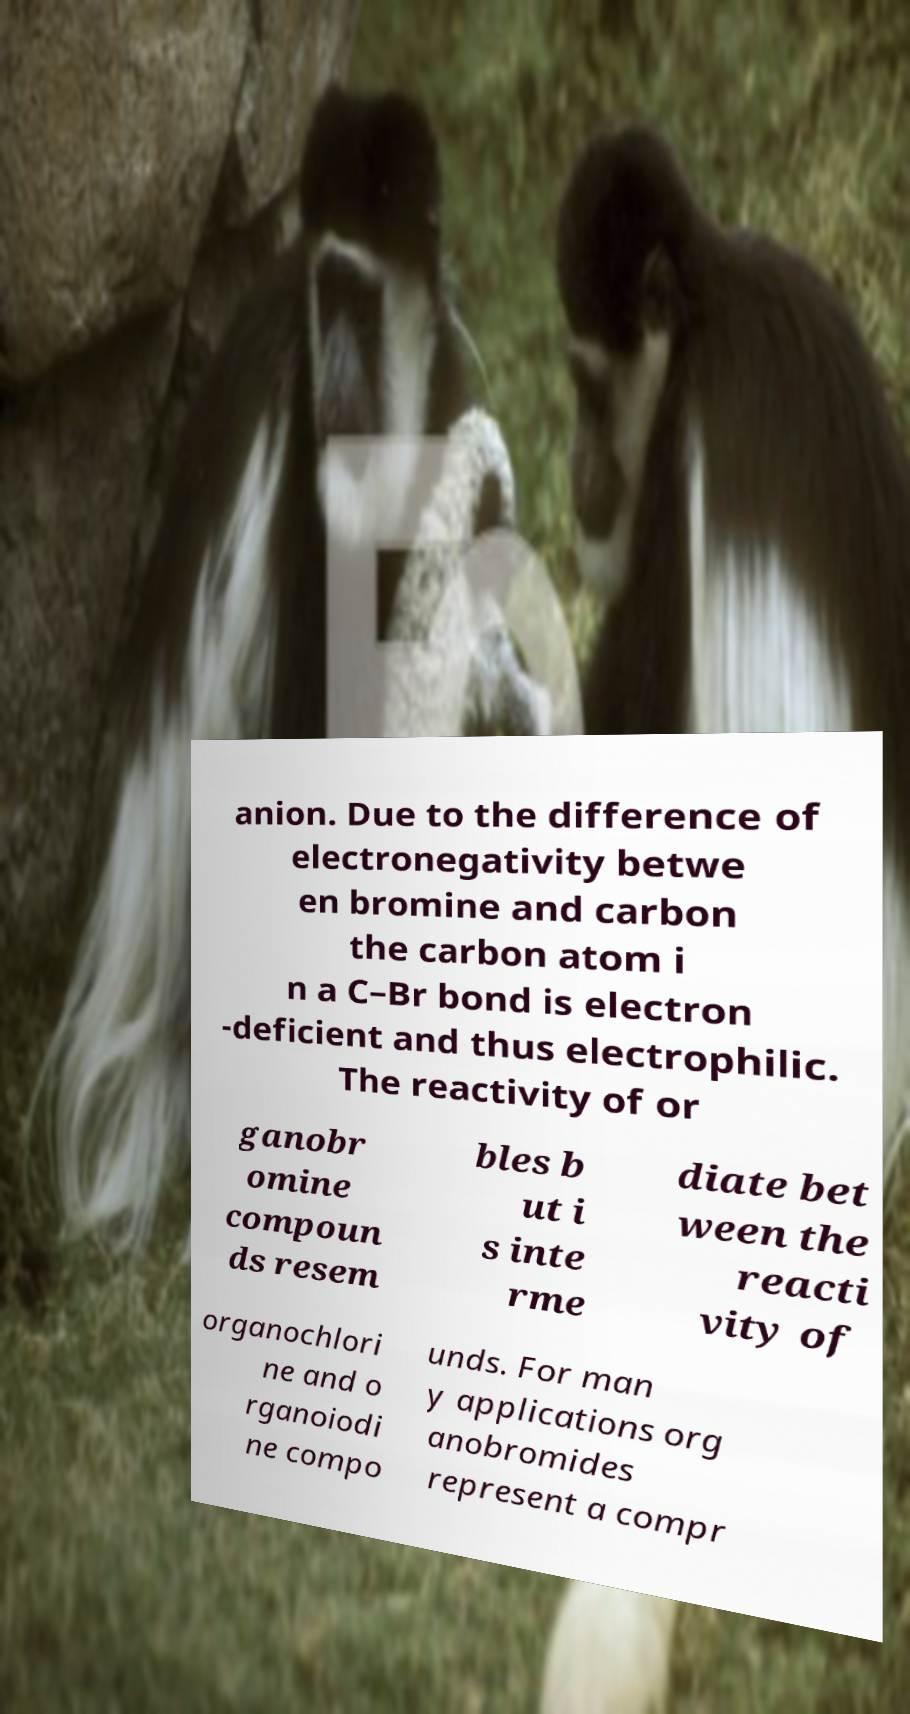There's text embedded in this image that I need extracted. Can you transcribe it verbatim? anion. Due to the difference of electronegativity betwe en bromine and carbon the carbon atom i n a C–Br bond is electron -deficient and thus electrophilic. The reactivity of or ganobr omine compoun ds resem bles b ut i s inte rme diate bet ween the reacti vity of organochlori ne and o rganoiodi ne compo unds. For man y applications org anobromides represent a compr 